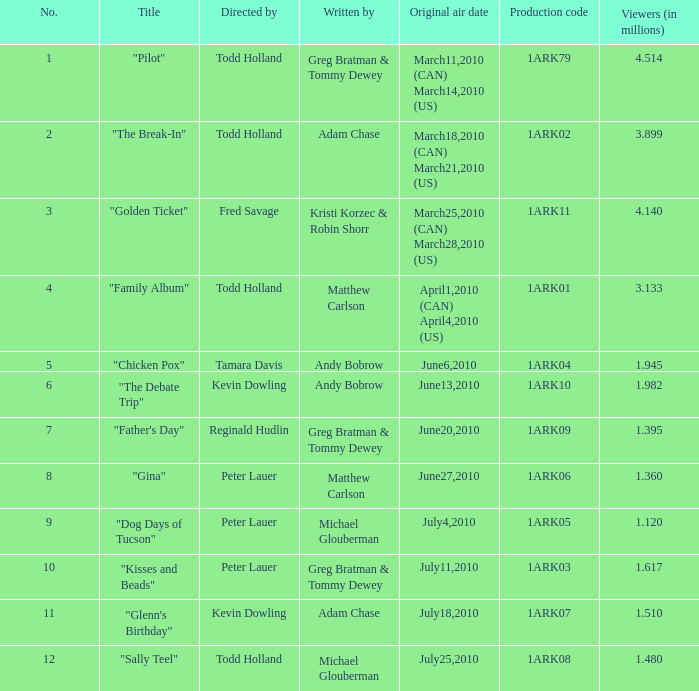How many millions of people viewed "Father's Day"? 1.395. 